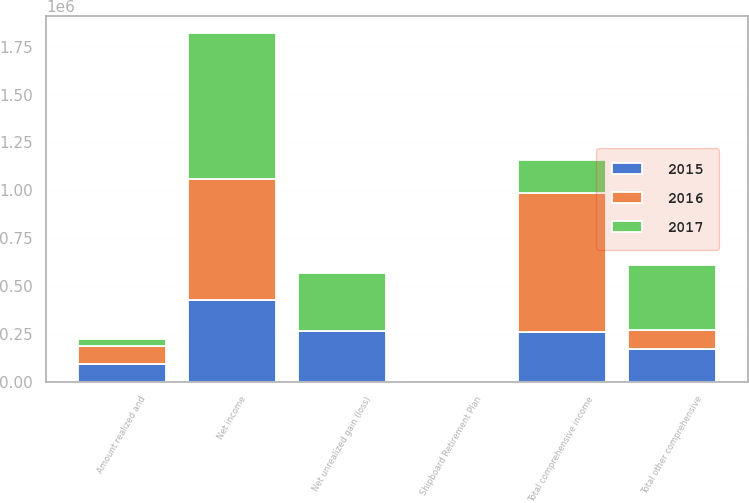Convert chart to OTSL. <chart><loc_0><loc_0><loc_500><loc_500><stacked_bar_chart><ecel><fcel>Net income<fcel>Shipboard Retirement Plan<fcel>Net unrealized gain (loss)<fcel>Amount realized and<fcel>Total other comprehensive<fcel>Total comprehensive income<nl><fcel>2017<fcel>759872<fcel>40<fcel>304684<fcel>36795<fcel>341439<fcel>170008<nl><fcel>2016<fcel>633085<fcel>497<fcel>1711<fcel>95969<fcel>98177<fcel>731262<nl><fcel>2015<fcel>427137<fcel>1102<fcel>262852<fcel>91742<fcel>170008<fcel>257129<nl></chart> 